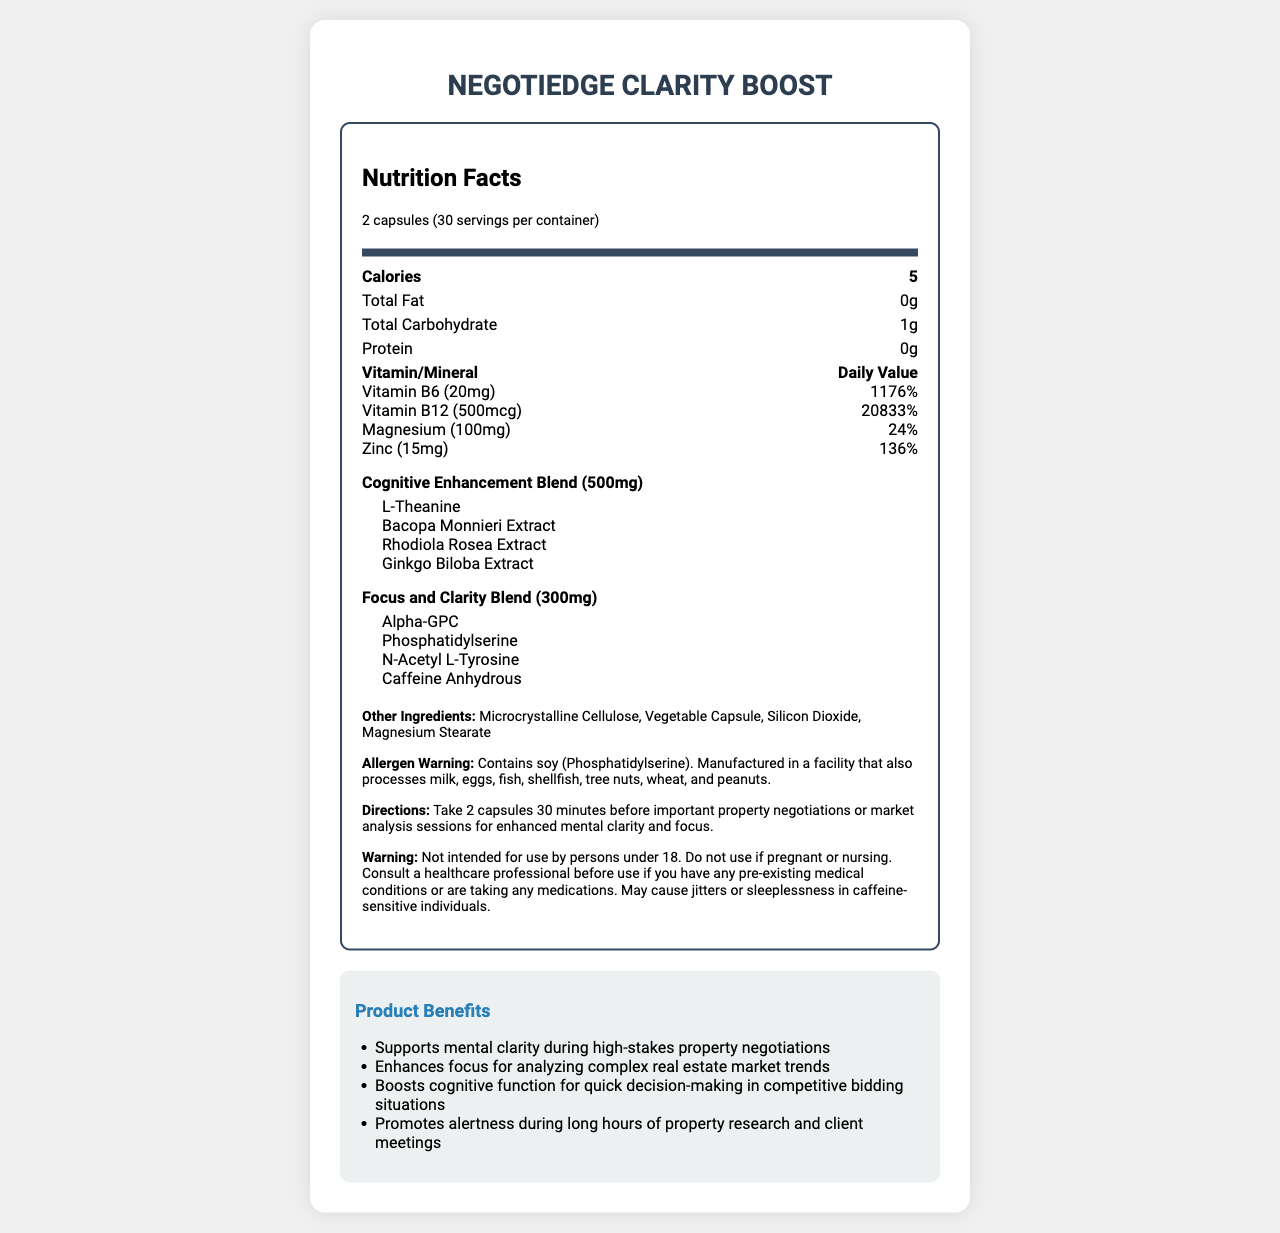what is the product name? The product name is listed at the top of the document.
Answer: NegotiEdge Clarity Boost what is the serving size? The serving size is mentioned under the serving information in the document.
Answer: 2 capsules how many servings are in one container? The number of servings per container is listed in the serving information.
Answer: 30 how many calories are there per serving? The calories per serving are stated in the nutrition facts section.
Answer: 5 calories which vitamin has the highest daily value percentage? Vitamin B12 has a daily value of 20833%, which is the highest among all listed vitamins and minerals.
Answer: Vitamin B12 how many grams of total carbohydrates are in one serving? The total carbohydrate content per serving is provided in the nutrition facts section.
Answer: 1g what is the main purpose of taking this supplement? The directions and marketing claims sections mention the supplement supports mental clarity and focus, especially during property negotiations.
Answer: Enhanced mental clarity and focus during property negotiations which ingredient might cause issues for someone with a soy allergy? The allergen warning states that the product contains soy (Phosphatidylserine).
Answer: Phosphatidylserine list two ingredients found in the Cognitive Enhancement Blend The Cognitive Enhancement Blend includes L-Theanine, Bacopa Monnieri Extract, Rhodiola Rosea Extract, and Ginkgo Biloba Extract.
Answer: L-Theanine, Bacopa Monnieri Extract what should you do before taking this supplement if you are pregnant? The warning section advises consulting a healthcare professional if pregnant.
Answer: Consult a healthcare professional what are the calories from total fat per serving? A. 0g B. 5g C. 10g The total fat content per serving is 0g, and therefore, the calories from fat would be 0g.
Answer: A. 0g which ingredient is part of the Focus and Clarity Blend? I. Alpha-GPC II. N-Acetyl L-Carnitine III. Phosphatidylserine IV. Caffeine Anhydrous The Focus and Clarity Blend includes Alpha-GPC, Phosphatidylserine, N-Acetyl L-Tyrosine, and Caffeine Anhydrous, while N-Acetyl L-Carnitine is not listed.
Answer: I, IV is this supplement intended for individuals under 18? The warning section explicitly states that the supplement is not intended for use by persons under 18.
Answer: No what is the main idea of the document? The document presents the nutritional facts, proprietary blends, other ingredients, allergen warnings, directions for use, and marketing claims to explain the supplement's purpose and benefits.
Answer: The document provides detailed nutritional information, ingredient lists, warnings, and benefits of the NegotiEdge Clarity Boost vitamin supplement, designed to enhance mental clarity and focus during property negotiations and market analysis. what is the exact amount of L-Theanine in the proprietary blend? The document lists L-Theanine as an ingredient in the Cognitive Enhancement Blend but does not provide the exact amount of L-Theanine individually.
Answer: Not enough information 